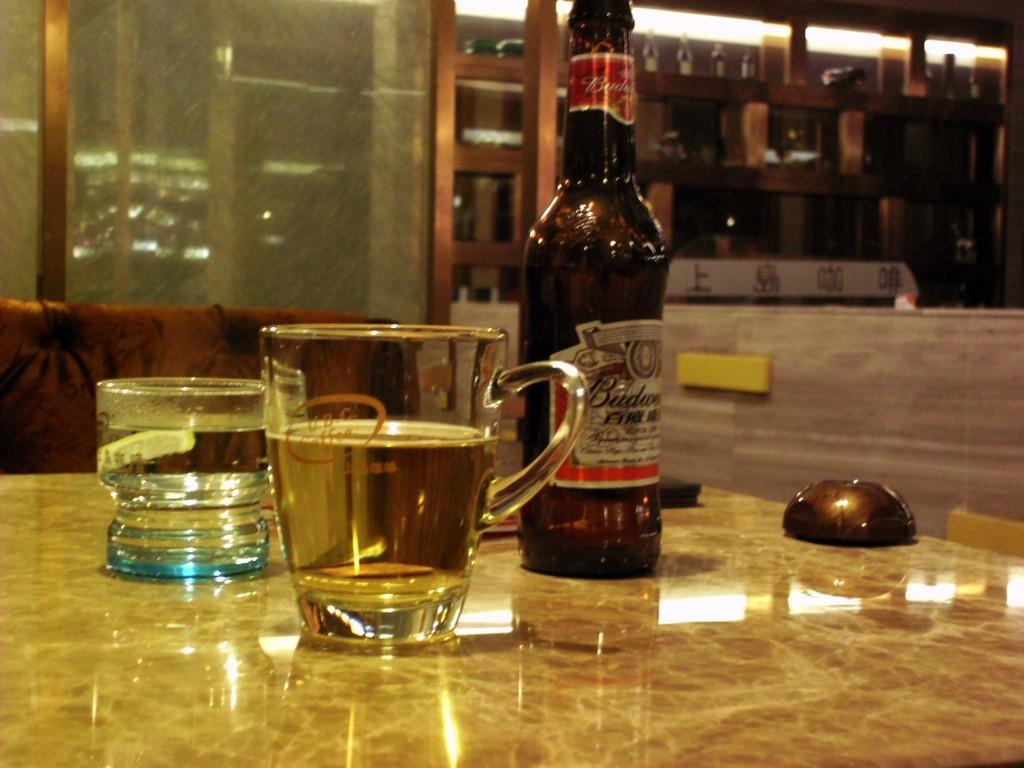Provide a one-sentence caption for the provided image. A table in a bar with two glasses and a Budweiser bottle. 